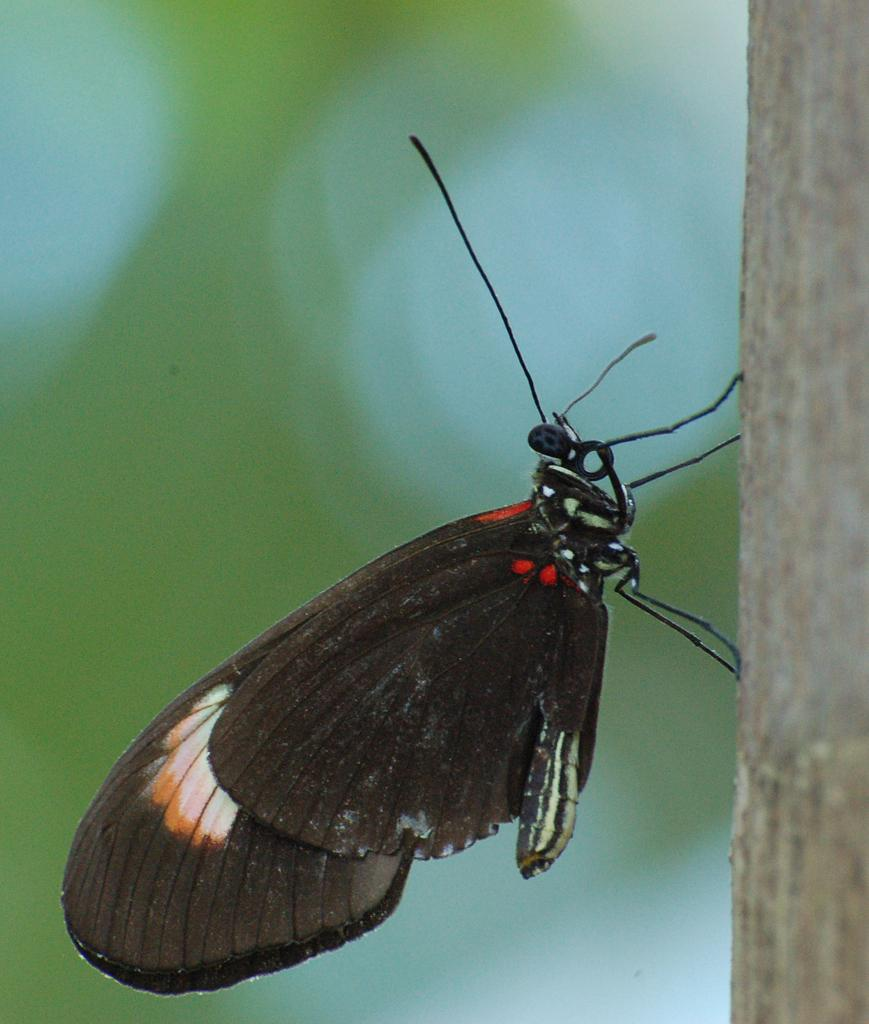What type of animal can be seen in the image? There is a butterfly in the image. Where is the butterfly located? The butterfly is on the bark of a tree. What type of art is the girl creating with the string in the image? There is no girl or string present in the image; it only features a butterfly on the bark of a tree. 